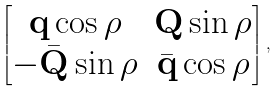Convert formula to latex. <formula><loc_0><loc_0><loc_500><loc_500>\begin{bmatrix} \mathbf q \cos \rho & \mathbf Q \sin \rho \\ - \bar { \mathbf Q } \sin \rho & \bar { \mathbf q } \cos \rho \end{bmatrix} ,</formula> 